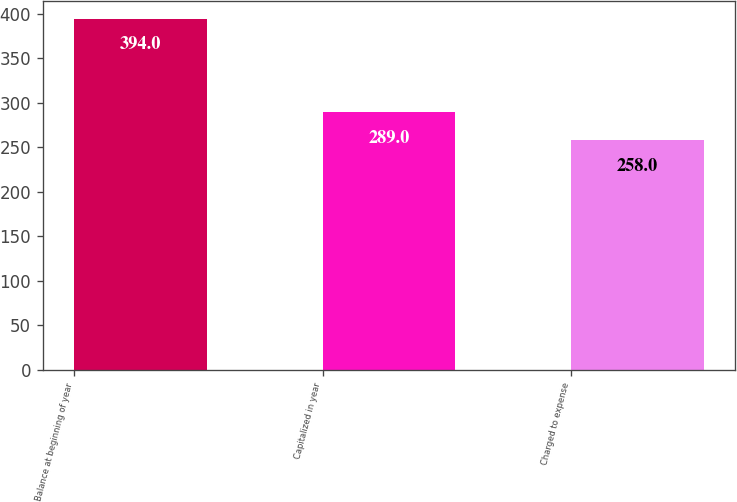Convert chart to OTSL. <chart><loc_0><loc_0><loc_500><loc_500><bar_chart><fcel>Balance at beginning of year<fcel>Capitalized in year<fcel>Charged to expense<nl><fcel>394<fcel>289<fcel>258<nl></chart> 